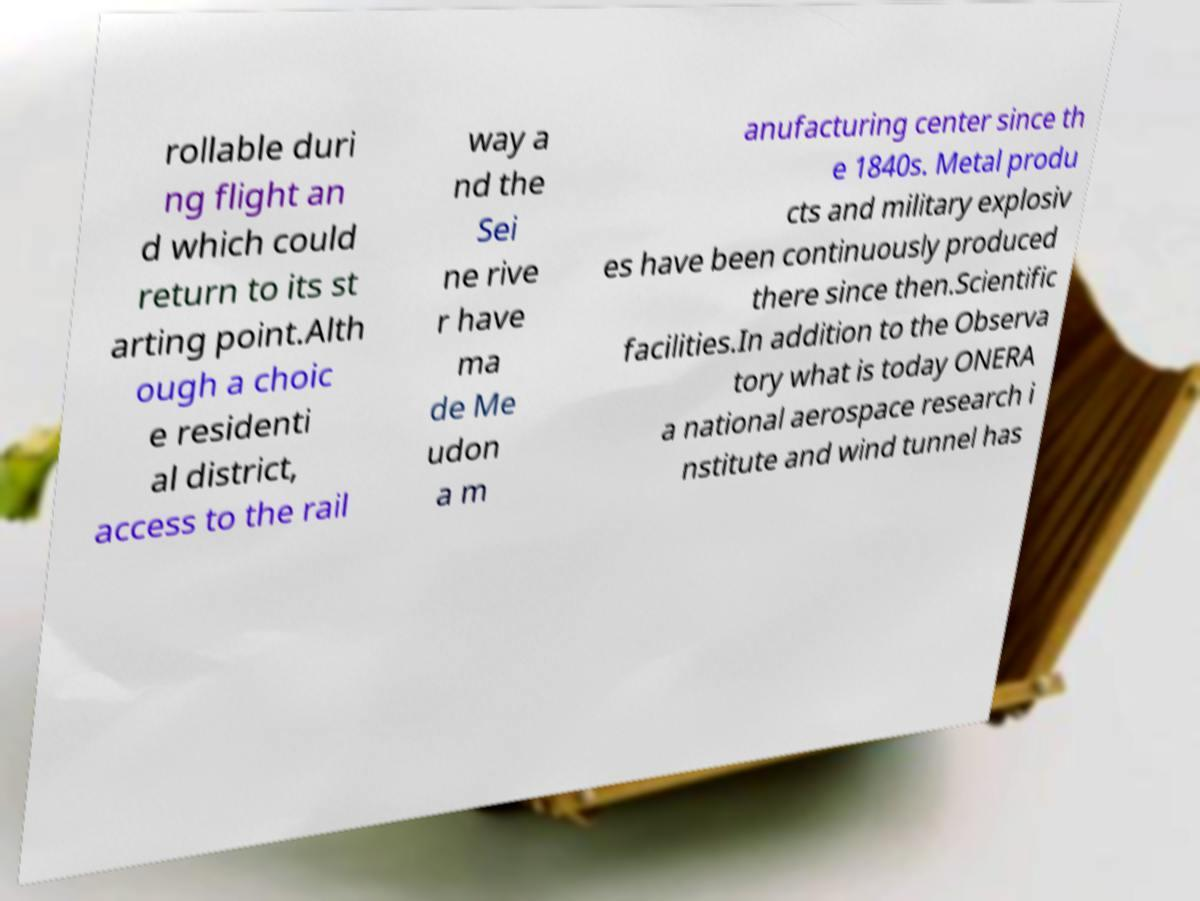Please identify and transcribe the text found in this image. rollable duri ng flight an d which could return to its st arting point.Alth ough a choic e residenti al district, access to the rail way a nd the Sei ne rive r have ma de Me udon a m anufacturing center since th e 1840s. Metal produ cts and military explosiv es have been continuously produced there since then.Scientific facilities.In addition to the Observa tory what is today ONERA a national aerospace research i nstitute and wind tunnel has 